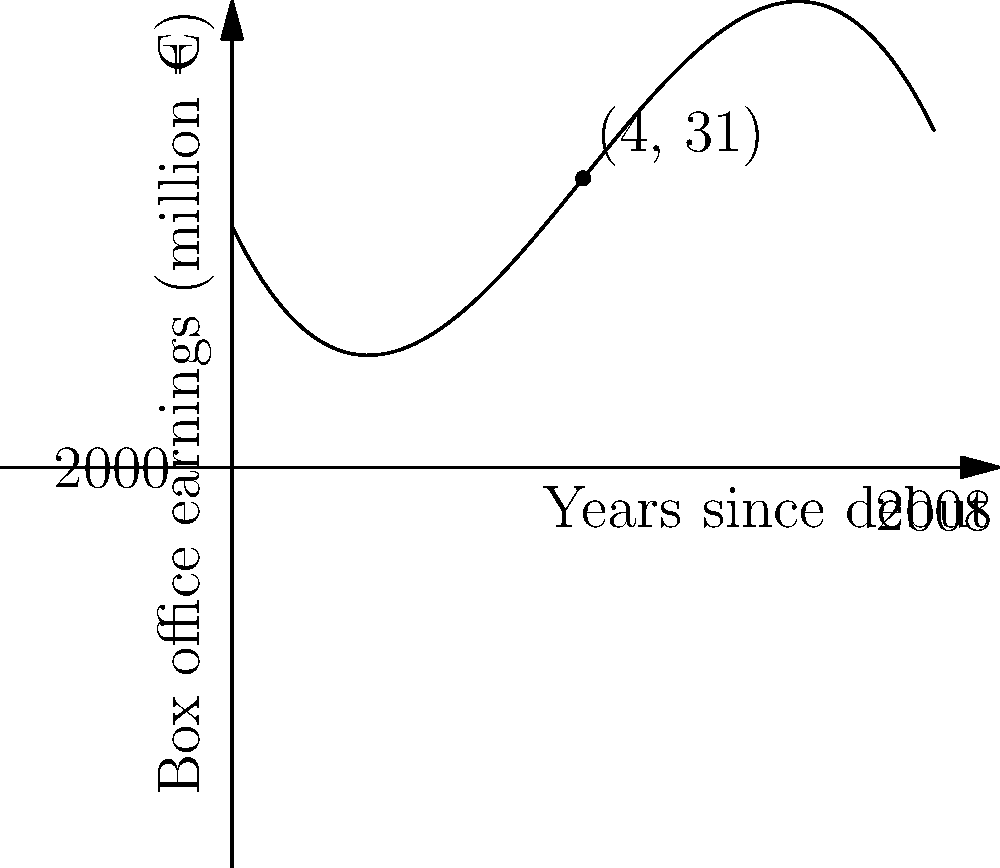The graph represents the trend of Santiago Segura's film box office earnings in Spain from 2000 to 2008. If this trend is modeled by the polynomial function $f(x) = -0.5x^3 + 6x^2 - 15x + 20$, where $x$ represents the years since 2000, at which point does the curve reach its maximum? To find the maximum point of the curve, we need to follow these steps:

1. The maximum point occurs where the derivative of the function equals zero.

2. Let's calculate the derivative of $f(x)$:
   $f'(x) = -1.5x^2 + 12x - 15$

3. Set the derivative equal to zero and solve for x:
   $-1.5x^2 + 12x - 15 = 0$

4. This is a quadratic equation. We can solve it using the quadratic formula:
   $x = \frac{-b \pm \sqrt{b^2 - 4ac}}{2a}$

   Where $a = -1.5$, $b = 12$, and $c = -15$

5. Plugging in these values:
   $x = \frac{-12 \pm \sqrt{12^2 - 4(-1.5)(-15)}}{2(-1.5)}$

6. Simplifying:
   $x = \frac{-12 \pm \sqrt{144 - 90}}{-3} = \frac{-12 \pm \sqrt{54}}{-3} = \frac{-12 \pm 3\sqrt{6}}{-3}$

7. This gives us two solutions:
   $x_1 = 4 + \sqrt{6}$ and $x_2 = 4 - \sqrt{6}$

8. Since we're looking for the maximum point, and the curve opens downward (negative coefficient for $x^3$), we choose the smaller value: $x = 4 - \sqrt{6} \approx 1.55$

9. However, since we're dealing with years, and the question asks for the point on the curve, we round to the nearest whole number: 2.

10. This corresponds to the year 2002 (2 years after 2000).

Therefore, the maximum point on the curve occurs approximately 2 years after 2000, which is 2002.
Answer: 2002 